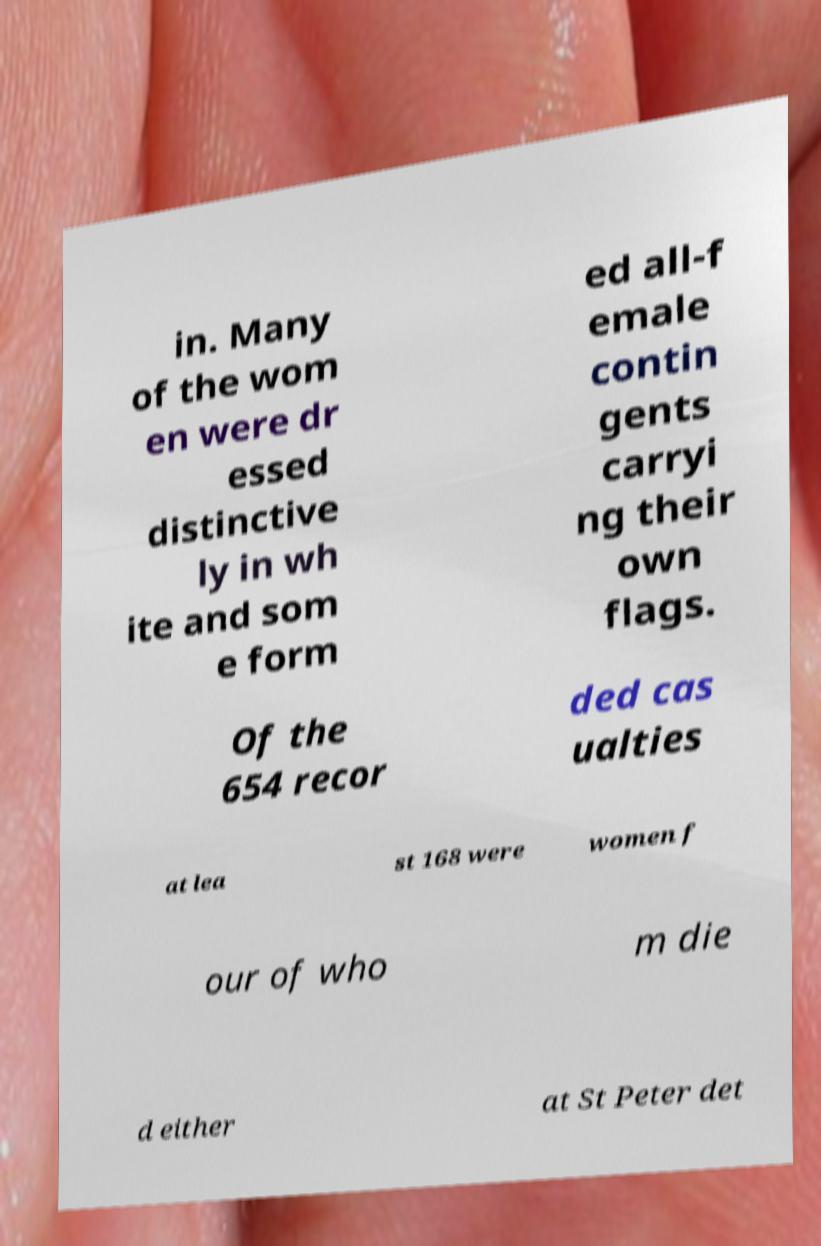Can you read and provide the text displayed in the image?This photo seems to have some interesting text. Can you extract and type it out for me? in. Many of the wom en were dr essed distinctive ly in wh ite and som e form ed all-f emale contin gents carryi ng their own flags. Of the 654 recor ded cas ualties at lea st 168 were women f our of who m die d either at St Peter det 